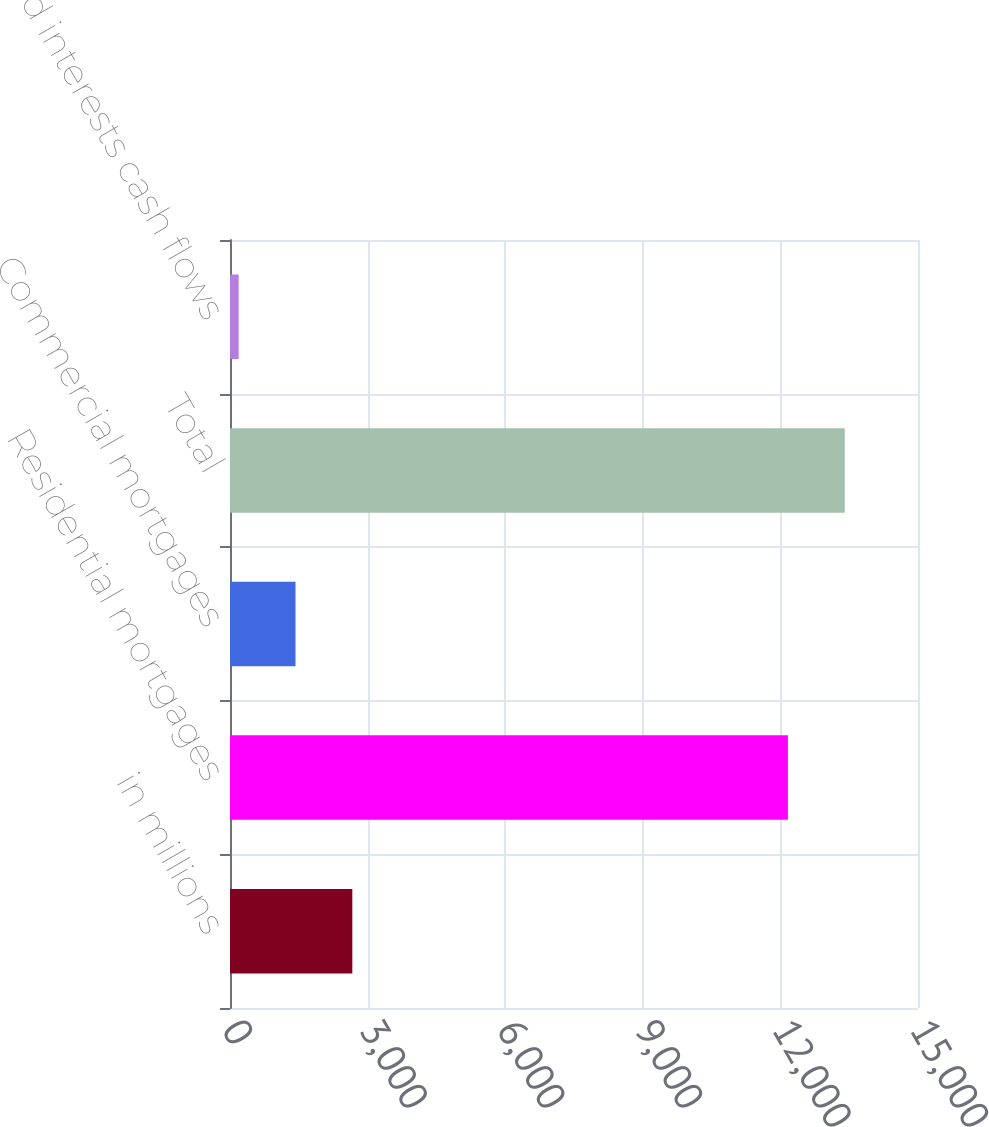Convert chart. <chart><loc_0><loc_0><loc_500><loc_500><bar_chart><fcel>in millions<fcel>Residential mortgages<fcel>Commercial mortgages<fcel>Total<fcel>Retained interests cash flows<nl><fcel>2666.8<fcel>12164<fcel>1427.9<fcel>13402.9<fcel>189<nl></chart> 